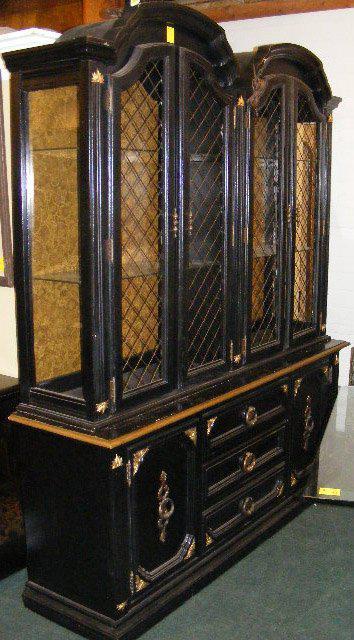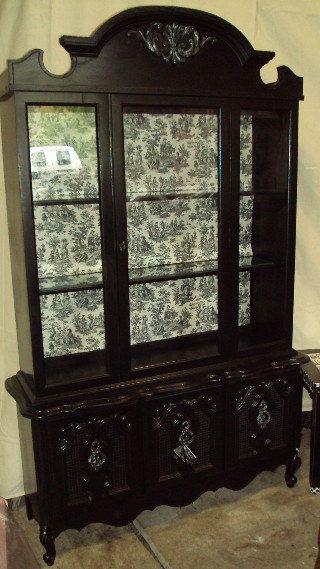The first image is the image on the left, the second image is the image on the right. Analyze the images presented: Is the assertion "None of the cabinets are empty." valid? Answer yes or no. No. 